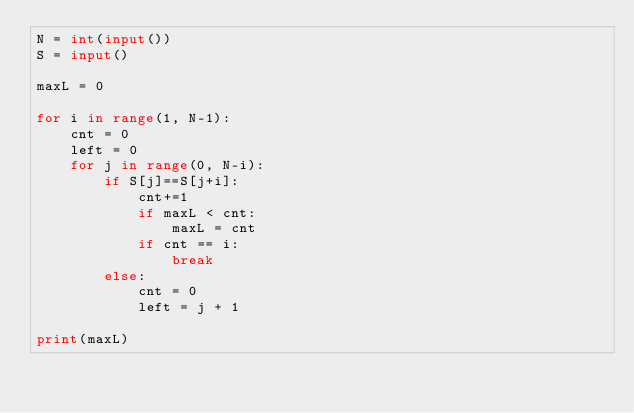Convert code to text. <code><loc_0><loc_0><loc_500><loc_500><_Python_>N = int(input())
S = input()

maxL = 0

for i in range(1, N-1):
    cnt = 0
    left = 0
    for j in range(0, N-i):
        if S[j]==S[j+i]:
            cnt+=1
            if maxL < cnt:
                maxL = cnt
            if cnt == i:
                break
        else:
            cnt = 0
            left = j + 1

print(maxL)</code> 